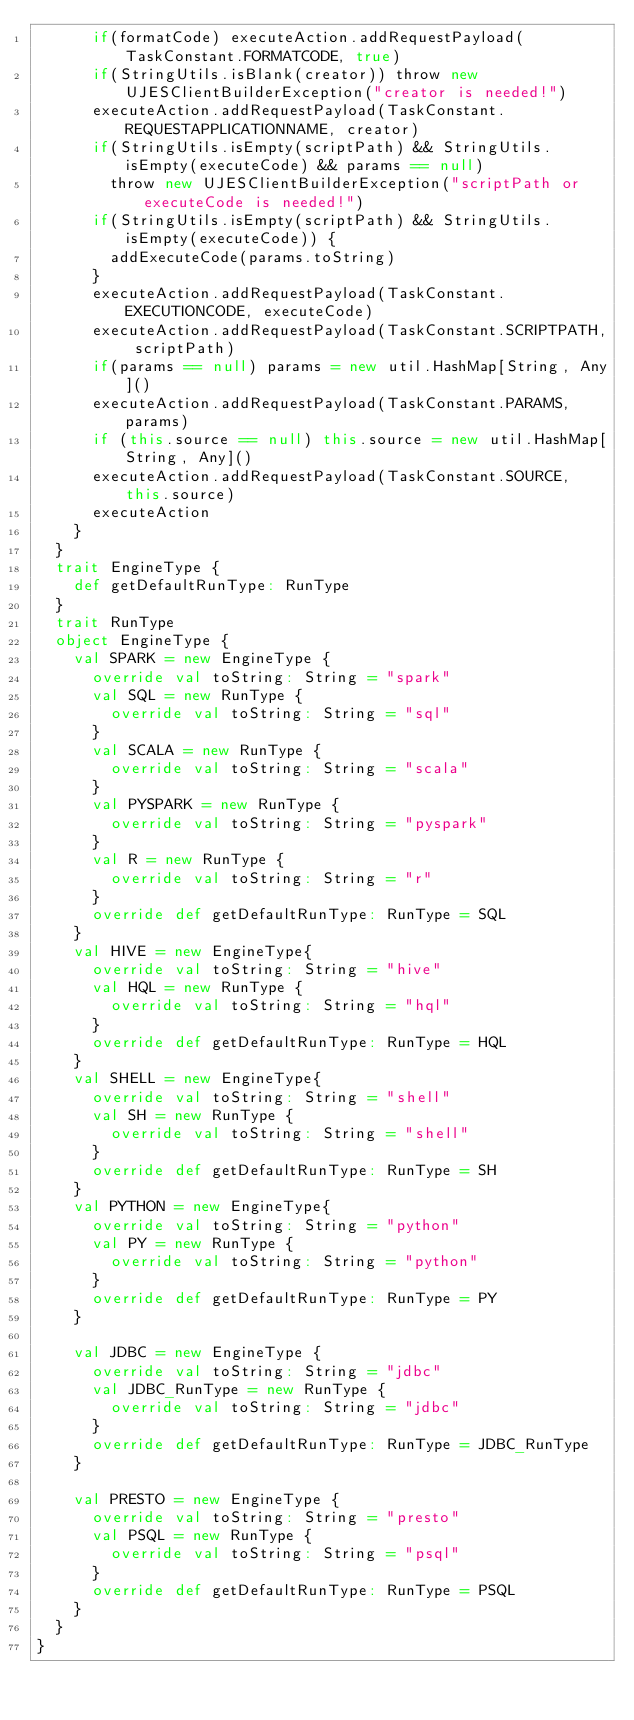<code> <loc_0><loc_0><loc_500><loc_500><_Scala_>      if(formatCode) executeAction.addRequestPayload(TaskConstant.FORMATCODE, true)
      if(StringUtils.isBlank(creator)) throw new UJESClientBuilderException("creator is needed!")
      executeAction.addRequestPayload(TaskConstant.REQUESTAPPLICATIONNAME, creator)
      if(StringUtils.isEmpty(scriptPath) && StringUtils.isEmpty(executeCode) && params == null)
        throw new UJESClientBuilderException("scriptPath or executeCode is needed!")
      if(StringUtils.isEmpty(scriptPath) && StringUtils.isEmpty(executeCode)) {
        addExecuteCode(params.toString)
      }
      executeAction.addRequestPayload(TaskConstant.EXECUTIONCODE, executeCode)
      executeAction.addRequestPayload(TaskConstant.SCRIPTPATH, scriptPath)
      if(params == null) params = new util.HashMap[String, Any]()
      executeAction.addRequestPayload(TaskConstant.PARAMS, params)
      if (this.source == null) this.source = new util.HashMap[String, Any]()
      executeAction.addRequestPayload(TaskConstant.SOURCE, this.source)
      executeAction
    }
  }
  trait EngineType {
    def getDefaultRunType: RunType
  }
  trait RunType
  object EngineType {
    val SPARK = new EngineType {
      override val toString: String = "spark"
      val SQL = new RunType {
        override val toString: String = "sql"
      }
      val SCALA = new RunType {
        override val toString: String = "scala"
      }
      val PYSPARK = new RunType {
        override val toString: String = "pyspark"
      }
      val R = new RunType {
        override val toString: String = "r"
      }
      override def getDefaultRunType: RunType = SQL
    }
    val HIVE = new EngineType{
      override val toString: String = "hive"
      val HQL = new RunType {
        override val toString: String = "hql"
      }
      override def getDefaultRunType: RunType = HQL
    }
    val SHELL = new EngineType{
      override val toString: String = "shell"
      val SH = new RunType {
        override val toString: String = "shell"
      }
      override def getDefaultRunType: RunType = SH
    }
    val PYTHON = new EngineType{
      override val toString: String = "python"
      val PY = new RunType {
        override val toString: String = "python"
      }
      override def getDefaultRunType: RunType = PY
    }

    val JDBC = new EngineType {
      override val toString: String = "jdbc"
      val JDBC_RunType = new RunType {
        override val toString: String = "jdbc"
      }
      override def getDefaultRunType: RunType = JDBC_RunType
    }

    val PRESTO = new EngineType {
      override val toString: String = "presto"
      val PSQL = new RunType {
        override val toString: String = "psql"
      }
      override def getDefaultRunType: RunType = PSQL
    }
  }
}
</code> 